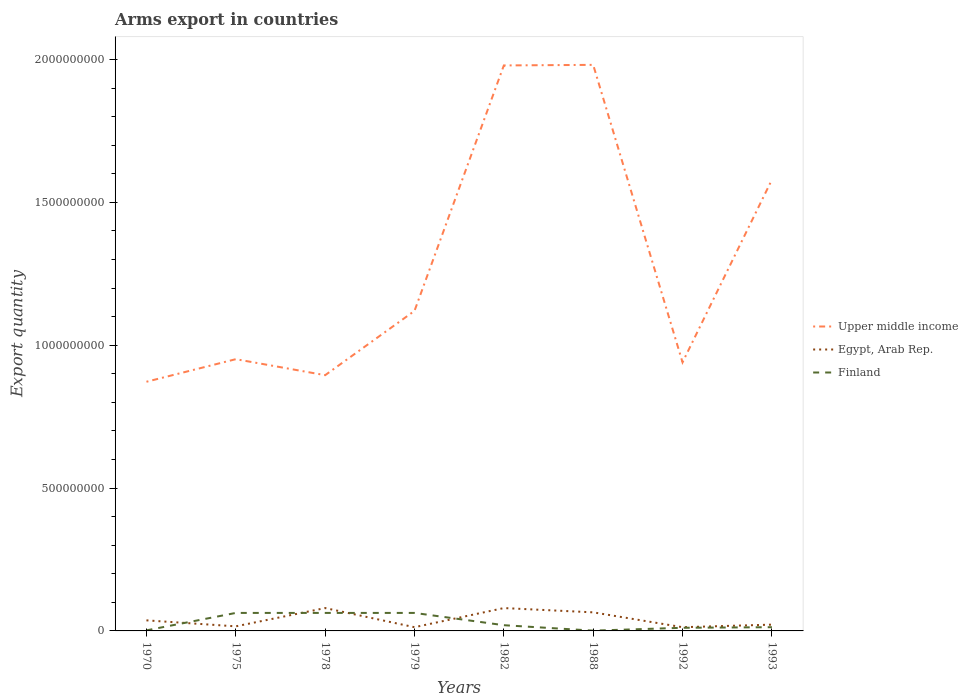How many different coloured lines are there?
Make the answer very short. 3. Does the line corresponding to Egypt, Arab Rep. intersect with the line corresponding to Finland?
Give a very brief answer. Yes. Across all years, what is the maximum total arms export in Upper middle income?
Ensure brevity in your answer.  8.72e+08. What is the total total arms export in Egypt, Arab Rep. in the graph?
Provide a succinct answer. 5.20e+07. What is the difference between the highest and the second highest total arms export in Egypt, Arab Rep.?
Offer a very short reply. 6.70e+07. What is the difference between the highest and the lowest total arms export in Finland?
Make the answer very short. 3. How many lines are there?
Your response must be concise. 3. How many years are there in the graph?
Give a very brief answer. 8. What is the difference between two consecutive major ticks on the Y-axis?
Make the answer very short. 5.00e+08. Does the graph contain grids?
Your response must be concise. No. How many legend labels are there?
Provide a short and direct response. 3. How are the legend labels stacked?
Keep it short and to the point. Vertical. What is the title of the graph?
Your answer should be compact. Arms export in countries. What is the label or title of the X-axis?
Keep it short and to the point. Years. What is the label or title of the Y-axis?
Give a very brief answer. Export quantity. What is the Export quantity in Upper middle income in 1970?
Provide a succinct answer. 8.72e+08. What is the Export quantity in Egypt, Arab Rep. in 1970?
Your answer should be compact. 3.70e+07. What is the Export quantity of Upper middle income in 1975?
Your response must be concise. 9.51e+08. What is the Export quantity in Egypt, Arab Rep. in 1975?
Give a very brief answer. 1.60e+07. What is the Export quantity of Finland in 1975?
Offer a very short reply. 6.30e+07. What is the Export quantity of Upper middle income in 1978?
Your answer should be compact. 8.95e+08. What is the Export quantity in Egypt, Arab Rep. in 1978?
Your answer should be compact. 8.00e+07. What is the Export quantity of Finland in 1978?
Ensure brevity in your answer.  6.30e+07. What is the Export quantity in Upper middle income in 1979?
Keep it short and to the point. 1.12e+09. What is the Export quantity in Egypt, Arab Rep. in 1979?
Provide a short and direct response. 1.30e+07. What is the Export quantity in Finland in 1979?
Provide a succinct answer. 6.30e+07. What is the Export quantity in Upper middle income in 1982?
Keep it short and to the point. 1.98e+09. What is the Export quantity of Egypt, Arab Rep. in 1982?
Ensure brevity in your answer.  8.00e+07. What is the Export quantity of Finland in 1982?
Offer a terse response. 2.00e+07. What is the Export quantity of Upper middle income in 1988?
Keep it short and to the point. 1.98e+09. What is the Export quantity in Egypt, Arab Rep. in 1988?
Provide a succinct answer. 6.50e+07. What is the Export quantity of Finland in 1988?
Your answer should be very brief. 1.00e+06. What is the Export quantity in Upper middle income in 1992?
Your response must be concise. 9.40e+08. What is the Export quantity in Egypt, Arab Rep. in 1992?
Your response must be concise. 1.30e+07. What is the Export quantity of Finland in 1992?
Your response must be concise. 1.10e+07. What is the Export quantity in Upper middle income in 1993?
Provide a succinct answer. 1.58e+09. What is the Export quantity of Egypt, Arab Rep. in 1993?
Your answer should be very brief. 2.20e+07. What is the Export quantity in Finland in 1993?
Ensure brevity in your answer.  1.30e+07. Across all years, what is the maximum Export quantity in Upper middle income?
Keep it short and to the point. 1.98e+09. Across all years, what is the maximum Export quantity of Egypt, Arab Rep.?
Make the answer very short. 8.00e+07. Across all years, what is the maximum Export quantity in Finland?
Offer a very short reply. 6.30e+07. Across all years, what is the minimum Export quantity of Upper middle income?
Offer a very short reply. 8.72e+08. Across all years, what is the minimum Export quantity in Egypt, Arab Rep.?
Provide a short and direct response. 1.30e+07. Across all years, what is the minimum Export quantity in Finland?
Ensure brevity in your answer.  1.00e+06. What is the total Export quantity in Upper middle income in the graph?
Keep it short and to the point. 1.03e+1. What is the total Export quantity of Egypt, Arab Rep. in the graph?
Your response must be concise. 3.26e+08. What is the total Export quantity in Finland in the graph?
Offer a very short reply. 2.36e+08. What is the difference between the Export quantity of Upper middle income in 1970 and that in 1975?
Keep it short and to the point. -7.90e+07. What is the difference between the Export quantity in Egypt, Arab Rep. in 1970 and that in 1975?
Provide a short and direct response. 2.10e+07. What is the difference between the Export quantity in Finland in 1970 and that in 1975?
Your answer should be compact. -6.10e+07. What is the difference between the Export quantity in Upper middle income in 1970 and that in 1978?
Provide a short and direct response. -2.30e+07. What is the difference between the Export quantity in Egypt, Arab Rep. in 1970 and that in 1978?
Offer a very short reply. -4.30e+07. What is the difference between the Export quantity of Finland in 1970 and that in 1978?
Provide a succinct answer. -6.10e+07. What is the difference between the Export quantity of Upper middle income in 1970 and that in 1979?
Offer a terse response. -2.48e+08. What is the difference between the Export quantity of Egypt, Arab Rep. in 1970 and that in 1979?
Ensure brevity in your answer.  2.40e+07. What is the difference between the Export quantity of Finland in 1970 and that in 1979?
Provide a short and direct response. -6.10e+07. What is the difference between the Export quantity of Upper middle income in 1970 and that in 1982?
Your answer should be very brief. -1.11e+09. What is the difference between the Export quantity in Egypt, Arab Rep. in 1970 and that in 1982?
Give a very brief answer. -4.30e+07. What is the difference between the Export quantity of Finland in 1970 and that in 1982?
Provide a succinct answer. -1.80e+07. What is the difference between the Export quantity of Upper middle income in 1970 and that in 1988?
Make the answer very short. -1.11e+09. What is the difference between the Export quantity of Egypt, Arab Rep. in 1970 and that in 1988?
Provide a short and direct response. -2.80e+07. What is the difference between the Export quantity in Upper middle income in 1970 and that in 1992?
Keep it short and to the point. -6.80e+07. What is the difference between the Export quantity in Egypt, Arab Rep. in 1970 and that in 1992?
Provide a short and direct response. 2.40e+07. What is the difference between the Export quantity in Finland in 1970 and that in 1992?
Ensure brevity in your answer.  -9.00e+06. What is the difference between the Export quantity in Upper middle income in 1970 and that in 1993?
Make the answer very short. -7.07e+08. What is the difference between the Export quantity in Egypt, Arab Rep. in 1970 and that in 1993?
Make the answer very short. 1.50e+07. What is the difference between the Export quantity in Finland in 1970 and that in 1993?
Make the answer very short. -1.10e+07. What is the difference between the Export quantity of Upper middle income in 1975 and that in 1978?
Your response must be concise. 5.60e+07. What is the difference between the Export quantity of Egypt, Arab Rep. in 1975 and that in 1978?
Offer a terse response. -6.40e+07. What is the difference between the Export quantity of Upper middle income in 1975 and that in 1979?
Your answer should be compact. -1.69e+08. What is the difference between the Export quantity of Finland in 1975 and that in 1979?
Provide a succinct answer. 0. What is the difference between the Export quantity of Upper middle income in 1975 and that in 1982?
Provide a short and direct response. -1.03e+09. What is the difference between the Export quantity in Egypt, Arab Rep. in 1975 and that in 1982?
Your answer should be very brief. -6.40e+07. What is the difference between the Export quantity of Finland in 1975 and that in 1982?
Your answer should be very brief. 4.30e+07. What is the difference between the Export quantity in Upper middle income in 1975 and that in 1988?
Ensure brevity in your answer.  -1.03e+09. What is the difference between the Export quantity in Egypt, Arab Rep. in 1975 and that in 1988?
Your response must be concise. -4.90e+07. What is the difference between the Export quantity of Finland in 1975 and that in 1988?
Your answer should be very brief. 6.20e+07. What is the difference between the Export quantity of Upper middle income in 1975 and that in 1992?
Offer a very short reply. 1.10e+07. What is the difference between the Export quantity of Finland in 1975 and that in 1992?
Offer a terse response. 5.20e+07. What is the difference between the Export quantity in Upper middle income in 1975 and that in 1993?
Offer a very short reply. -6.28e+08. What is the difference between the Export quantity in Egypt, Arab Rep. in 1975 and that in 1993?
Keep it short and to the point. -6.00e+06. What is the difference between the Export quantity of Finland in 1975 and that in 1993?
Make the answer very short. 5.00e+07. What is the difference between the Export quantity of Upper middle income in 1978 and that in 1979?
Offer a very short reply. -2.25e+08. What is the difference between the Export quantity of Egypt, Arab Rep. in 1978 and that in 1979?
Ensure brevity in your answer.  6.70e+07. What is the difference between the Export quantity of Upper middle income in 1978 and that in 1982?
Give a very brief answer. -1.08e+09. What is the difference between the Export quantity in Egypt, Arab Rep. in 1978 and that in 1982?
Ensure brevity in your answer.  0. What is the difference between the Export quantity of Finland in 1978 and that in 1982?
Your answer should be very brief. 4.30e+07. What is the difference between the Export quantity of Upper middle income in 1978 and that in 1988?
Your answer should be compact. -1.09e+09. What is the difference between the Export quantity in Egypt, Arab Rep. in 1978 and that in 1988?
Make the answer very short. 1.50e+07. What is the difference between the Export quantity in Finland in 1978 and that in 1988?
Your answer should be very brief. 6.20e+07. What is the difference between the Export quantity of Upper middle income in 1978 and that in 1992?
Provide a short and direct response. -4.50e+07. What is the difference between the Export quantity of Egypt, Arab Rep. in 1978 and that in 1992?
Make the answer very short. 6.70e+07. What is the difference between the Export quantity of Finland in 1978 and that in 1992?
Provide a short and direct response. 5.20e+07. What is the difference between the Export quantity in Upper middle income in 1978 and that in 1993?
Your response must be concise. -6.84e+08. What is the difference between the Export quantity in Egypt, Arab Rep. in 1978 and that in 1993?
Your response must be concise. 5.80e+07. What is the difference between the Export quantity in Finland in 1978 and that in 1993?
Your answer should be very brief. 5.00e+07. What is the difference between the Export quantity of Upper middle income in 1979 and that in 1982?
Make the answer very short. -8.59e+08. What is the difference between the Export quantity in Egypt, Arab Rep. in 1979 and that in 1982?
Offer a very short reply. -6.70e+07. What is the difference between the Export quantity in Finland in 1979 and that in 1982?
Offer a very short reply. 4.30e+07. What is the difference between the Export quantity in Upper middle income in 1979 and that in 1988?
Your answer should be compact. -8.61e+08. What is the difference between the Export quantity of Egypt, Arab Rep. in 1979 and that in 1988?
Your response must be concise. -5.20e+07. What is the difference between the Export quantity of Finland in 1979 and that in 1988?
Your response must be concise. 6.20e+07. What is the difference between the Export quantity of Upper middle income in 1979 and that in 1992?
Keep it short and to the point. 1.80e+08. What is the difference between the Export quantity of Egypt, Arab Rep. in 1979 and that in 1992?
Give a very brief answer. 0. What is the difference between the Export quantity of Finland in 1979 and that in 1992?
Your answer should be compact. 5.20e+07. What is the difference between the Export quantity in Upper middle income in 1979 and that in 1993?
Your answer should be very brief. -4.59e+08. What is the difference between the Export quantity of Egypt, Arab Rep. in 1979 and that in 1993?
Your response must be concise. -9.00e+06. What is the difference between the Export quantity in Finland in 1979 and that in 1993?
Offer a terse response. 5.00e+07. What is the difference between the Export quantity in Upper middle income in 1982 and that in 1988?
Your response must be concise. -2.00e+06. What is the difference between the Export quantity of Egypt, Arab Rep. in 1982 and that in 1988?
Keep it short and to the point. 1.50e+07. What is the difference between the Export quantity of Finland in 1982 and that in 1988?
Your response must be concise. 1.90e+07. What is the difference between the Export quantity of Upper middle income in 1982 and that in 1992?
Offer a very short reply. 1.04e+09. What is the difference between the Export quantity in Egypt, Arab Rep. in 1982 and that in 1992?
Your answer should be very brief. 6.70e+07. What is the difference between the Export quantity in Finland in 1982 and that in 1992?
Ensure brevity in your answer.  9.00e+06. What is the difference between the Export quantity of Upper middle income in 1982 and that in 1993?
Make the answer very short. 4.00e+08. What is the difference between the Export quantity in Egypt, Arab Rep. in 1982 and that in 1993?
Offer a terse response. 5.80e+07. What is the difference between the Export quantity of Upper middle income in 1988 and that in 1992?
Give a very brief answer. 1.04e+09. What is the difference between the Export quantity in Egypt, Arab Rep. in 1988 and that in 1992?
Ensure brevity in your answer.  5.20e+07. What is the difference between the Export quantity in Finland in 1988 and that in 1992?
Provide a succinct answer. -1.00e+07. What is the difference between the Export quantity of Upper middle income in 1988 and that in 1993?
Your response must be concise. 4.02e+08. What is the difference between the Export quantity in Egypt, Arab Rep. in 1988 and that in 1993?
Provide a succinct answer. 4.30e+07. What is the difference between the Export quantity of Finland in 1988 and that in 1993?
Your response must be concise. -1.20e+07. What is the difference between the Export quantity of Upper middle income in 1992 and that in 1993?
Offer a very short reply. -6.39e+08. What is the difference between the Export quantity of Egypt, Arab Rep. in 1992 and that in 1993?
Provide a succinct answer. -9.00e+06. What is the difference between the Export quantity in Finland in 1992 and that in 1993?
Give a very brief answer. -2.00e+06. What is the difference between the Export quantity of Upper middle income in 1970 and the Export quantity of Egypt, Arab Rep. in 1975?
Provide a short and direct response. 8.56e+08. What is the difference between the Export quantity in Upper middle income in 1970 and the Export quantity in Finland in 1975?
Your answer should be compact. 8.09e+08. What is the difference between the Export quantity in Egypt, Arab Rep. in 1970 and the Export quantity in Finland in 1975?
Provide a succinct answer. -2.60e+07. What is the difference between the Export quantity of Upper middle income in 1970 and the Export quantity of Egypt, Arab Rep. in 1978?
Provide a short and direct response. 7.92e+08. What is the difference between the Export quantity of Upper middle income in 1970 and the Export quantity of Finland in 1978?
Provide a succinct answer. 8.09e+08. What is the difference between the Export quantity in Egypt, Arab Rep. in 1970 and the Export quantity in Finland in 1978?
Provide a succinct answer. -2.60e+07. What is the difference between the Export quantity of Upper middle income in 1970 and the Export quantity of Egypt, Arab Rep. in 1979?
Provide a short and direct response. 8.59e+08. What is the difference between the Export quantity in Upper middle income in 1970 and the Export quantity in Finland in 1979?
Offer a very short reply. 8.09e+08. What is the difference between the Export quantity in Egypt, Arab Rep. in 1970 and the Export quantity in Finland in 1979?
Your response must be concise. -2.60e+07. What is the difference between the Export quantity in Upper middle income in 1970 and the Export quantity in Egypt, Arab Rep. in 1982?
Keep it short and to the point. 7.92e+08. What is the difference between the Export quantity in Upper middle income in 1970 and the Export quantity in Finland in 1982?
Your answer should be very brief. 8.52e+08. What is the difference between the Export quantity of Egypt, Arab Rep. in 1970 and the Export quantity of Finland in 1982?
Offer a very short reply. 1.70e+07. What is the difference between the Export quantity in Upper middle income in 1970 and the Export quantity in Egypt, Arab Rep. in 1988?
Ensure brevity in your answer.  8.07e+08. What is the difference between the Export quantity of Upper middle income in 1970 and the Export quantity of Finland in 1988?
Your answer should be compact. 8.71e+08. What is the difference between the Export quantity of Egypt, Arab Rep. in 1970 and the Export quantity of Finland in 1988?
Offer a very short reply. 3.60e+07. What is the difference between the Export quantity of Upper middle income in 1970 and the Export quantity of Egypt, Arab Rep. in 1992?
Give a very brief answer. 8.59e+08. What is the difference between the Export quantity of Upper middle income in 1970 and the Export quantity of Finland in 1992?
Provide a succinct answer. 8.61e+08. What is the difference between the Export quantity in Egypt, Arab Rep. in 1970 and the Export quantity in Finland in 1992?
Make the answer very short. 2.60e+07. What is the difference between the Export quantity in Upper middle income in 1970 and the Export quantity in Egypt, Arab Rep. in 1993?
Provide a short and direct response. 8.50e+08. What is the difference between the Export quantity in Upper middle income in 1970 and the Export quantity in Finland in 1993?
Make the answer very short. 8.59e+08. What is the difference between the Export quantity of Egypt, Arab Rep. in 1970 and the Export quantity of Finland in 1993?
Give a very brief answer. 2.40e+07. What is the difference between the Export quantity of Upper middle income in 1975 and the Export quantity of Egypt, Arab Rep. in 1978?
Offer a terse response. 8.71e+08. What is the difference between the Export quantity of Upper middle income in 1975 and the Export quantity of Finland in 1978?
Offer a very short reply. 8.88e+08. What is the difference between the Export quantity in Egypt, Arab Rep. in 1975 and the Export quantity in Finland in 1978?
Keep it short and to the point. -4.70e+07. What is the difference between the Export quantity of Upper middle income in 1975 and the Export quantity of Egypt, Arab Rep. in 1979?
Offer a terse response. 9.38e+08. What is the difference between the Export quantity in Upper middle income in 1975 and the Export quantity in Finland in 1979?
Your answer should be compact. 8.88e+08. What is the difference between the Export quantity of Egypt, Arab Rep. in 1975 and the Export quantity of Finland in 1979?
Provide a succinct answer. -4.70e+07. What is the difference between the Export quantity of Upper middle income in 1975 and the Export quantity of Egypt, Arab Rep. in 1982?
Provide a short and direct response. 8.71e+08. What is the difference between the Export quantity in Upper middle income in 1975 and the Export quantity in Finland in 1982?
Your answer should be compact. 9.31e+08. What is the difference between the Export quantity of Egypt, Arab Rep. in 1975 and the Export quantity of Finland in 1982?
Offer a terse response. -4.00e+06. What is the difference between the Export quantity of Upper middle income in 1975 and the Export quantity of Egypt, Arab Rep. in 1988?
Offer a very short reply. 8.86e+08. What is the difference between the Export quantity in Upper middle income in 1975 and the Export quantity in Finland in 1988?
Provide a succinct answer. 9.50e+08. What is the difference between the Export quantity in Egypt, Arab Rep. in 1975 and the Export quantity in Finland in 1988?
Offer a very short reply. 1.50e+07. What is the difference between the Export quantity of Upper middle income in 1975 and the Export quantity of Egypt, Arab Rep. in 1992?
Provide a succinct answer. 9.38e+08. What is the difference between the Export quantity of Upper middle income in 1975 and the Export quantity of Finland in 1992?
Provide a short and direct response. 9.40e+08. What is the difference between the Export quantity of Upper middle income in 1975 and the Export quantity of Egypt, Arab Rep. in 1993?
Your answer should be very brief. 9.29e+08. What is the difference between the Export quantity of Upper middle income in 1975 and the Export quantity of Finland in 1993?
Offer a terse response. 9.38e+08. What is the difference between the Export quantity in Egypt, Arab Rep. in 1975 and the Export quantity in Finland in 1993?
Ensure brevity in your answer.  3.00e+06. What is the difference between the Export quantity in Upper middle income in 1978 and the Export quantity in Egypt, Arab Rep. in 1979?
Offer a terse response. 8.82e+08. What is the difference between the Export quantity in Upper middle income in 1978 and the Export quantity in Finland in 1979?
Your response must be concise. 8.32e+08. What is the difference between the Export quantity in Egypt, Arab Rep. in 1978 and the Export quantity in Finland in 1979?
Ensure brevity in your answer.  1.70e+07. What is the difference between the Export quantity in Upper middle income in 1978 and the Export quantity in Egypt, Arab Rep. in 1982?
Ensure brevity in your answer.  8.15e+08. What is the difference between the Export quantity of Upper middle income in 1978 and the Export quantity of Finland in 1982?
Make the answer very short. 8.75e+08. What is the difference between the Export quantity of Egypt, Arab Rep. in 1978 and the Export quantity of Finland in 1982?
Provide a short and direct response. 6.00e+07. What is the difference between the Export quantity in Upper middle income in 1978 and the Export quantity in Egypt, Arab Rep. in 1988?
Offer a terse response. 8.30e+08. What is the difference between the Export quantity of Upper middle income in 1978 and the Export quantity of Finland in 1988?
Your answer should be very brief. 8.94e+08. What is the difference between the Export quantity of Egypt, Arab Rep. in 1978 and the Export quantity of Finland in 1988?
Provide a short and direct response. 7.90e+07. What is the difference between the Export quantity in Upper middle income in 1978 and the Export quantity in Egypt, Arab Rep. in 1992?
Your response must be concise. 8.82e+08. What is the difference between the Export quantity of Upper middle income in 1978 and the Export quantity of Finland in 1992?
Offer a terse response. 8.84e+08. What is the difference between the Export quantity in Egypt, Arab Rep. in 1978 and the Export quantity in Finland in 1992?
Offer a very short reply. 6.90e+07. What is the difference between the Export quantity in Upper middle income in 1978 and the Export quantity in Egypt, Arab Rep. in 1993?
Offer a terse response. 8.73e+08. What is the difference between the Export quantity of Upper middle income in 1978 and the Export quantity of Finland in 1993?
Your answer should be compact. 8.82e+08. What is the difference between the Export quantity in Egypt, Arab Rep. in 1978 and the Export quantity in Finland in 1993?
Your answer should be compact. 6.70e+07. What is the difference between the Export quantity in Upper middle income in 1979 and the Export quantity in Egypt, Arab Rep. in 1982?
Ensure brevity in your answer.  1.04e+09. What is the difference between the Export quantity of Upper middle income in 1979 and the Export quantity of Finland in 1982?
Ensure brevity in your answer.  1.10e+09. What is the difference between the Export quantity in Egypt, Arab Rep. in 1979 and the Export quantity in Finland in 1982?
Your answer should be very brief. -7.00e+06. What is the difference between the Export quantity of Upper middle income in 1979 and the Export quantity of Egypt, Arab Rep. in 1988?
Provide a succinct answer. 1.06e+09. What is the difference between the Export quantity of Upper middle income in 1979 and the Export quantity of Finland in 1988?
Your answer should be very brief. 1.12e+09. What is the difference between the Export quantity in Egypt, Arab Rep. in 1979 and the Export quantity in Finland in 1988?
Give a very brief answer. 1.20e+07. What is the difference between the Export quantity in Upper middle income in 1979 and the Export quantity in Egypt, Arab Rep. in 1992?
Provide a succinct answer. 1.11e+09. What is the difference between the Export quantity in Upper middle income in 1979 and the Export quantity in Finland in 1992?
Your response must be concise. 1.11e+09. What is the difference between the Export quantity of Egypt, Arab Rep. in 1979 and the Export quantity of Finland in 1992?
Your answer should be compact. 2.00e+06. What is the difference between the Export quantity of Upper middle income in 1979 and the Export quantity of Egypt, Arab Rep. in 1993?
Offer a terse response. 1.10e+09. What is the difference between the Export quantity in Upper middle income in 1979 and the Export quantity in Finland in 1993?
Ensure brevity in your answer.  1.11e+09. What is the difference between the Export quantity of Egypt, Arab Rep. in 1979 and the Export quantity of Finland in 1993?
Make the answer very short. 0. What is the difference between the Export quantity in Upper middle income in 1982 and the Export quantity in Egypt, Arab Rep. in 1988?
Your response must be concise. 1.91e+09. What is the difference between the Export quantity of Upper middle income in 1982 and the Export quantity of Finland in 1988?
Give a very brief answer. 1.98e+09. What is the difference between the Export quantity of Egypt, Arab Rep. in 1982 and the Export quantity of Finland in 1988?
Make the answer very short. 7.90e+07. What is the difference between the Export quantity of Upper middle income in 1982 and the Export quantity of Egypt, Arab Rep. in 1992?
Offer a terse response. 1.97e+09. What is the difference between the Export quantity in Upper middle income in 1982 and the Export quantity in Finland in 1992?
Provide a succinct answer. 1.97e+09. What is the difference between the Export quantity of Egypt, Arab Rep. in 1982 and the Export quantity of Finland in 1992?
Provide a succinct answer. 6.90e+07. What is the difference between the Export quantity in Upper middle income in 1982 and the Export quantity in Egypt, Arab Rep. in 1993?
Give a very brief answer. 1.96e+09. What is the difference between the Export quantity in Upper middle income in 1982 and the Export quantity in Finland in 1993?
Your answer should be compact. 1.97e+09. What is the difference between the Export quantity in Egypt, Arab Rep. in 1982 and the Export quantity in Finland in 1993?
Give a very brief answer. 6.70e+07. What is the difference between the Export quantity in Upper middle income in 1988 and the Export quantity in Egypt, Arab Rep. in 1992?
Provide a short and direct response. 1.97e+09. What is the difference between the Export quantity of Upper middle income in 1988 and the Export quantity of Finland in 1992?
Offer a terse response. 1.97e+09. What is the difference between the Export quantity in Egypt, Arab Rep. in 1988 and the Export quantity in Finland in 1992?
Your response must be concise. 5.40e+07. What is the difference between the Export quantity in Upper middle income in 1988 and the Export quantity in Egypt, Arab Rep. in 1993?
Provide a succinct answer. 1.96e+09. What is the difference between the Export quantity in Upper middle income in 1988 and the Export quantity in Finland in 1993?
Your response must be concise. 1.97e+09. What is the difference between the Export quantity in Egypt, Arab Rep. in 1988 and the Export quantity in Finland in 1993?
Provide a succinct answer. 5.20e+07. What is the difference between the Export quantity in Upper middle income in 1992 and the Export quantity in Egypt, Arab Rep. in 1993?
Your answer should be very brief. 9.18e+08. What is the difference between the Export quantity of Upper middle income in 1992 and the Export quantity of Finland in 1993?
Provide a succinct answer. 9.27e+08. What is the average Export quantity of Upper middle income per year?
Provide a succinct answer. 1.29e+09. What is the average Export quantity in Egypt, Arab Rep. per year?
Give a very brief answer. 4.08e+07. What is the average Export quantity of Finland per year?
Offer a terse response. 2.95e+07. In the year 1970, what is the difference between the Export quantity of Upper middle income and Export quantity of Egypt, Arab Rep.?
Offer a terse response. 8.35e+08. In the year 1970, what is the difference between the Export quantity of Upper middle income and Export quantity of Finland?
Make the answer very short. 8.70e+08. In the year 1970, what is the difference between the Export quantity in Egypt, Arab Rep. and Export quantity in Finland?
Your answer should be very brief. 3.50e+07. In the year 1975, what is the difference between the Export quantity of Upper middle income and Export quantity of Egypt, Arab Rep.?
Keep it short and to the point. 9.35e+08. In the year 1975, what is the difference between the Export quantity in Upper middle income and Export quantity in Finland?
Keep it short and to the point. 8.88e+08. In the year 1975, what is the difference between the Export quantity of Egypt, Arab Rep. and Export quantity of Finland?
Offer a very short reply. -4.70e+07. In the year 1978, what is the difference between the Export quantity of Upper middle income and Export quantity of Egypt, Arab Rep.?
Provide a succinct answer. 8.15e+08. In the year 1978, what is the difference between the Export quantity of Upper middle income and Export quantity of Finland?
Your response must be concise. 8.32e+08. In the year 1978, what is the difference between the Export quantity in Egypt, Arab Rep. and Export quantity in Finland?
Your answer should be very brief. 1.70e+07. In the year 1979, what is the difference between the Export quantity of Upper middle income and Export quantity of Egypt, Arab Rep.?
Provide a succinct answer. 1.11e+09. In the year 1979, what is the difference between the Export quantity of Upper middle income and Export quantity of Finland?
Ensure brevity in your answer.  1.06e+09. In the year 1979, what is the difference between the Export quantity of Egypt, Arab Rep. and Export quantity of Finland?
Make the answer very short. -5.00e+07. In the year 1982, what is the difference between the Export quantity in Upper middle income and Export quantity in Egypt, Arab Rep.?
Your answer should be compact. 1.90e+09. In the year 1982, what is the difference between the Export quantity in Upper middle income and Export quantity in Finland?
Your answer should be compact. 1.96e+09. In the year 1982, what is the difference between the Export quantity in Egypt, Arab Rep. and Export quantity in Finland?
Keep it short and to the point. 6.00e+07. In the year 1988, what is the difference between the Export quantity of Upper middle income and Export quantity of Egypt, Arab Rep.?
Provide a short and direct response. 1.92e+09. In the year 1988, what is the difference between the Export quantity in Upper middle income and Export quantity in Finland?
Provide a succinct answer. 1.98e+09. In the year 1988, what is the difference between the Export quantity of Egypt, Arab Rep. and Export quantity of Finland?
Your response must be concise. 6.40e+07. In the year 1992, what is the difference between the Export quantity in Upper middle income and Export quantity in Egypt, Arab Rep.?
Your answer should be very brief. 9.27e+08. In the year 1992, what is the difference between the Export quantity of Upper middle income and Export quantity of Finland?
Your response must be concise. 9.29e+08. In the year 1993, what is the difference between the Export quantity in Upper middle income and Export quantity in Egypt, Arab Rep.?
Ensure brevity in your answer.  1.56e+09. In the year 1993, what is the difference between the Export quantity in Upper middle income and Export quantity in Finland?
Offer a very short reply. 1.57e+09. In the year 1993, what is the difference between the Export quantity of Egypt, Arab Rep. and Export quantity of Finland?
Your response must be concise. 9.00e+06. What is the ratio of the Export quantity in Upper middle income in 1970 to that in 1975?
Keep it short and to the point. 0.92. What is the ratio of the Export quantity of Egypt, Arab Rep. in 1970 to that in 1975?
Your answer should be very brief. 2.31. What is the ratio of the Export quantity in Finland in 1970 to that in 1975?
Provide a short and direct response. 0.03. What is the ratio of the Export quantity of Upper middle income in 1970 to that in 1978?
Your answer should be compact. 0.97. What is the ratio of the Export quantity in Egypt, Arab Rep. in 1970 to that in 1978?
Make the answer very short. 0.46. What is the ratio of the Export quantity in Finland in 1970 to that in 1978?
Keep it short and to the point. 0.03. What is the ratio of the Export quantity in Upper middle income in 1970 to that in 1979?
Provide a succinct answer. 0.78. What is the ratio of the Export quantity of Egypt, Arab Rep. in 1970 to that in 1979?
Your answer should be very brief. 2.85. What is the ratio of the Export quantity in Finland in 1970 to that in 1979?
Your response must be concise. 0.03. What is the ratio of the Export quantity of Upper middle income in 1970 to that in 1982?
Your response must be concise. 0.44. What is the ratio of the Export quantity in Egypt, Arab Rep. in 1970 to that in 1982?
Your answer should be compact. 0.46. What is the ratio of the Export quantity of Finland in 1970 to that in 1982?
Ensure brevity in your answer.  0.1. What is the ratio of the Export quantity in Upper middle income in 1970 to that in 1988?
Your answer should be compact. 0.44. What is the ratio of the Export quantity in Egypt, Arab Rep. in 1970 to that in 1988?
Your answer should be compact. 0.57. What is the ratio of the Export quantity in Finland in 1970 to that in 1988?
Provide a succinct answer. 2. What is the ratio of the Export quantity in Upper middle income in 1970 to that in 1992?
Give a very brief answer. 0.93. What is the ratio of the Export quantity of Egypt, Arab Rep. in 1970 to that in 1992?
Your answer should be compact. 2.85. What is the ratio of the Export quantity in Finland in 1970 to that in 1992?
Provide a short and direct response. 0.18. What is the ratio of the Export quantity in Upper middle income in 1970 to that in 1993?
Offer a very short reply. 0.55. What is the ratio of the Export quantity of Egypt, Arab Rep. in 1970 to that in 1993?
Your answer should be very brief. 1.68. What is the ratio of the Export quantity in Finland in 1970 to that in 1993?
Give a very brief answer. 0.15. What is the ratio of the Export quantity of Upper middle income in 1975 to that in 1978?
Keep it short and to the point. 1.06. What is the ratio of the Export quantity in Egypt, Arab Rep. in 1975 to that in 1978?
Ensure brevity in your answer.  0.2. What is the ratio of the Export quantity of Finland in 1975 to that in 1978?
Provide a succinct answer. 1. What is the ratio of the Export quantity in Upper middle income in 1975 to that in 1979?
Give a very brief answer. 0.85. What is the ratio of the Export quantity of Egypt, Arab Rep. in 1975 to that in 1979?
Your response must be concise. 1.23. What is the ratio of the Export quantity in Finland in 1975 to that in 1979?
Give a very brief answer. 1. What is the ratio of the Export quantity in Upper middle income in 1975 to that in 1982?
Your response must be concise. 0.48. What is the ratio of the Export quantity in Finland in 1975 to that in 1982?
Provide a succinct answer. 3.15. What is the ratio of the Export quantity in Upper middle income in 1975 to that in 1988?
Ensure brevity in your answer.  0.48. What is the ratio of the Export quantity of Egypt, Arab Rep. in 1975 to that in 1988?
Provide a succinct answer. 0.25. What is the ratio of the Export quantity in Finland in 1975 to that in 1988?
Your answer should be very brief. 63. What is the ratio of the Export quantity of Upper middle income in 1975 to that in 1992?
Your answer should be very brief. 1.01. What is the ratio of the Export quantity of Egypt, Arab Rep. in 1975 to that in 1992?
Your answer should be very brief. 1.23. What is the ratio of the Export quantity in Finland in 1975 to that in 1992?
Your response must be concise. 5.73. What is the ratio of the Export quantity in Upper middle income in 1975 to that in 1993?
Provide a succinct answer. 0.6. What is the ratio of the Export quantity in Egypt, Arab Rep. in 1975 to that in 1993?
Ensure brevity in your answer.  0.73. What is the ratio of the Export quantity in Finland in 1975 to that in 1993?
Offer a terse response. 4.85. What is the ratio of the Export quantity in Upper middle income in 1978 to that in 1979?
Your answer should be very brief. 0.8. What is the ratio of the Export quantity of Egypt, Arab Rep. in 1978 to that in 1979?
Offer a very short reply. 6.15. What is the ratio of the Export quantity of Upper middle income in 1978 to that in 1982?
Make the answer very short. 0.45. What is the ratio of the Export quantity in Egypt, Arab Rep. in 1978 to that in 1982?
Your answer should be compact. 1. What is the ratio of the Export quantity in Finland in 1978 to that in 1982?
Give a very brief answer. 3.15. What is the ratio of the Export quantity in Upper middle income in 1978 to that in 1988?
Your answer should be compact. 0.45. What is the ratio of the Export quantity in Egypt, Arab Rep. in 1978 to that in 1988?
Offer a very short reply. 1.23. What is the ratio of the Export quantity in Finland in 1978 to that in 1988?
Your answer should be compact. 63. What is the ratio of the Export quantity of Upper middle income in 1978 to that in 1992?
Provide a short and direct response. 0.95. What is the ratio of the Export quantity of Egypt, Arab Rep. in 1978 to that in 1992?
Ensure brevity in your answer.  6.15. What is the ratio of the Export quantity in Finland in 1978 to that in 1992?
Make the answer very short. 5.73. What is the ratio of the Export quantity in Upper middle income in 1978 to that in 1993?
Keep it short and to the point. 0.57. What is the ratio of the Export quantity in Egypt, Arab Rep. in 1978 to that in 1993?
Your answer should be very brief. 3.64. What is the ratio of the Export quantity in Finland in 1978 to that in 1993?
Your response must be concise. 4.85. What is the ratio of the Export quantity in Upper middle income in 1979 to that in 1982?
Provide a succinct answer. 0.57. What is the ratio of the Export quantity of Egypt, Arab Rep. in 1979 to that in 1982?
Your response must be concise. 0.16. What is the ratio of the Export quantity in Finland in 1979 to that in 1982?
Offer a terse response. 3.15. What is the ratio of the Export quantity in Upper middle income in 1979 to that in 1988?
Ensure brevity in your answer.  0.57. What is the ratio of the Export quantity of Upper middle income in 1979 to that in 1992?
Provide a short and direct response. 1.19. What is the ratio of the Export quantity in Egypt, Arab Rep. in 1979 to that in 1992?
Offer a terse response. 1. What is the ratio of the Export quantity of Finland in 1979 to that in 1992?
Keep it short and to the point. 5.73. What is the ratio of the Export quantity of Upper middle income in 1979 to that in 1993?
Provide a short and direct response. 0.71. What is the ratio of the Export quantity of Egypt, Arab Rep. in 1979 to that in 1993?
Offer a very short reply. 0.59. What is the ratio of the Export quantity in Finland in 1979 to that in 1993?
Offer a very short reply. 4.85. What is the ratio of the Export quantity of Egypt, Arab Rep. in 1982 to that in 1988?
Offer a terse response. 1.23. What is the ratio of the Export quantity in Finland in 1982 to that in 1988?
Ensure brevity in your answer.  20. What is the ratio of the Export quantity of Upper middle income in 1982 to that in 1992?
Your response must be concise. 2.11. What is the ratio of the Export quantity of Egypt, Arab Rep. in 1982 to that in 1992?
Your response must be concise. 6.15. What is the ratio of the Export quantity of Finland in 1982 to that in 1992?
Provide a short and direct response. 1.82. What is the ratio of the Export quantity in Upper middle income in 1982 to that in 1993?
Ensure brevity in your answer.  1.25. What is the ratio of the Export quantity in Egypt, Arab Rep. in 1982 to that in 1993?
Your response must be concise. 3.64. What is the ratio of the Export quantity of Finland in 1982 to that in 1993?
Offer a very short reply. 1.54. What is the ratio of the Export quantity of Upper middle income in 1988 to that in 1992?
Make the answer very short. 2.11. What is the ratio of the Export quantity of Finland in 1988 to that in 1992?
Your response must be concise. 0.09. What is the ratio of the Export quantity of Upper middle income in 1988 to that in 1993?
Provide a succinct answer. 1.25. What is the ratio of the Export quantity in Egypt, Arab Rep. in 1988 to that in 1993?
Keep it short and to the point. 2.95. What is the ratio of the Export quantity in Finland in 1988 to that in 1993?
Give a very brief answer. 0.08. What is the ratio of the Export quantity of Upper middle income in 1992 to that in 1993?
Provide a short and direct response. 0.6. What is the ratio of the Export quantity in Egypt, Arab Rep. in 1992 to that in 1993?
Offer a very short reply. 0.59. What is the ratio of the Export quantity in Finland in 1992 to that in 1993?
Give a very brief answer. 0.85. What is the difference between the highest and the second highest Export quantity in Upper middle income?
Make the answer very short. 2.00e+06. What is the difference between the highest and the lowest Export quantity in Upper middle income?
Offer a very short reply. 1.11e+09. What is the difference between the highest and the lowest Export quantity of Egypt, Arab Rep.?
Provide a succinct answer. 6.70e+07. What is the difference between the highest and the lowest Export quantity of Finland?
Offer a terse response. 6.20e+07. 